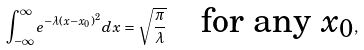<formula> <loc_0><loc_0><loc_500><loc_500>\int _ { - \infty } ^ { \infty } e ^ { - \lambda ( x - x _ { 0 } ) ^ { 2 } } d x = \sqrt { \frac { \pi } { \lambda } } \quad \text {for any $x_{0}$} ,</formula> 